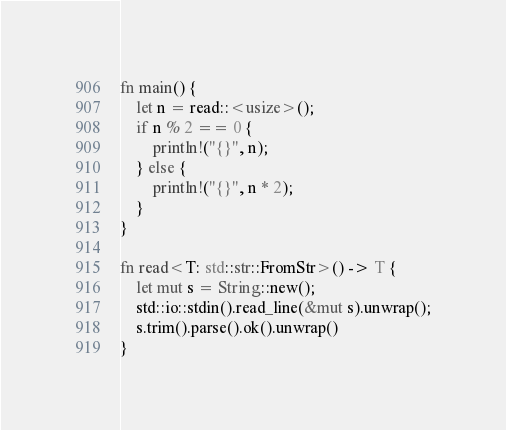<code> <loc_0><loc_0><loc_500><loc_500><_Rust_>fn main() {
    let n = read::<usize>();
    if n % 2 == 0 {
        println!("{}", n);
    } else {
        println!("{}", n * 2);
    }
}

fn read<T: std::str::FromStr>() -> T {
    let mut s = String::new();
    std::io::stdin().read_line(&mut s).unwrap();
    s.trim().parse().ok().unwrap()
}
</code> 